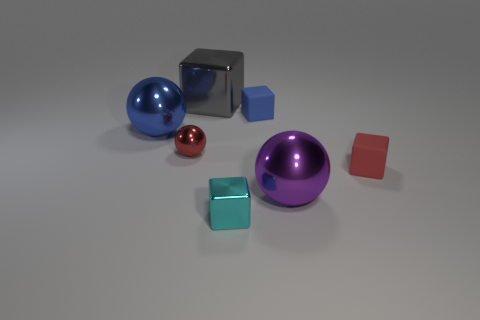Subtract all red blocks. How many blocks are left? 3 Subtract all cyan blocks. How many blocks are left? 3 Add 1 purple metal things. How many objects exist? 8 Subtract 1 blocks. How many blocks are left? 3 Subtract all spheres. How many objects are left? 4 Subtract all brown blocks. Subtract all blue balls. How many blocks are left? 4 Subtract all metallic balls. Subtract all blue metal balls. How many objects are left? 3 Add 3 big shiny cubes. How many big shiny cubes are left? 4 Add 7 red metallic balls. How many red metallic balls exist? 8 Subtract 0 brown balls. How many objects are left? 7 